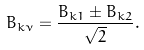<formula> <loc_0><loc_0><loc_500><loc_500>B _ { k \nu } = \frac { B _ { k 1 } \pm B _ { k 2 } } { \sqrt { 2 } } .</formula> 